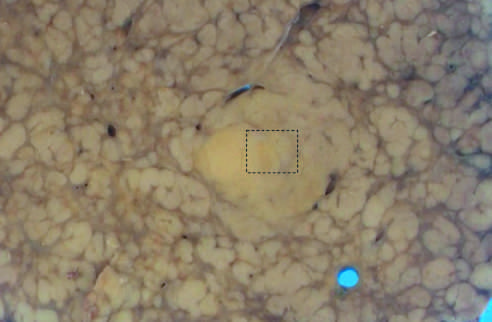does nodule-in-nodule growth suggest an evolving cancer?
Answer the question using a single word or phrase. Yes 